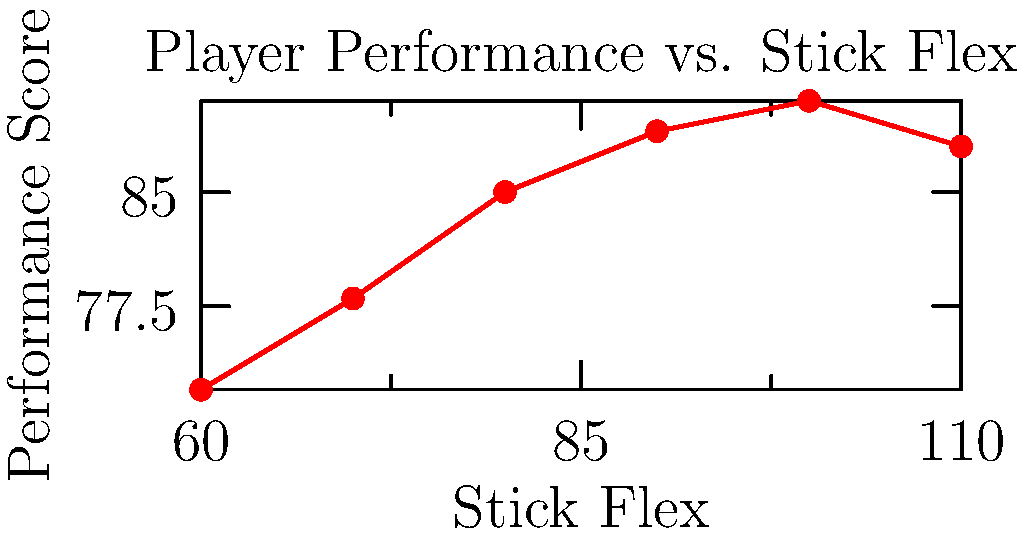Based on the line graph showing the relationship between stick flex and player performance, at which stick flex value does the player's performance appear to peak? To determine the stick flex value at which the player's performance peaks, we need to analyze the graph carefully:

1. The x-axis represents stick flex values, ranging from 60 to 110.
2. The y-axis represents performance scores.
3. As we move along the x-axis (increasing stick flex):
   - Performance increases from 60 to 100 flex
   - There's a slight decrease in performance after 100 flex

4. To find the peak, we look for the highest point on the graph:
   - The line reaches its highest point at x = 100

5. At x = 100, the y-value (performance score) is at its maximum.
6. After this point (at 110 flex), the performance slightly decreases.

Therefore, the player's performance appears to peak at a stick flex value of 100.
Answer: 100 